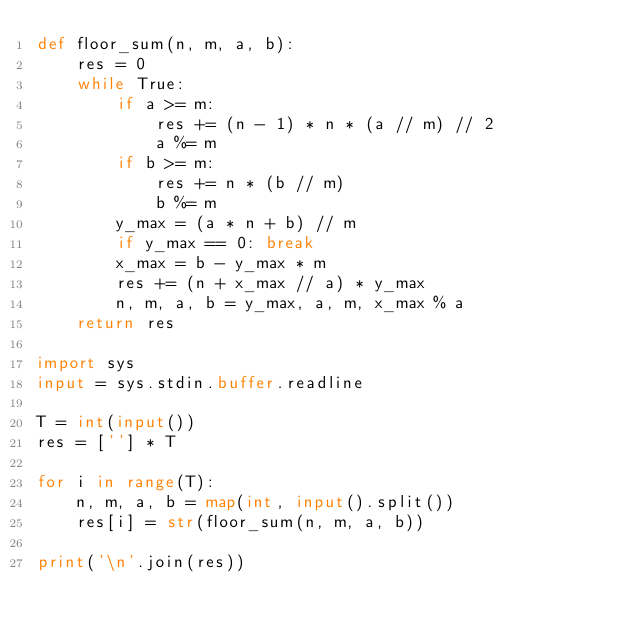Convert code to text. <code><loc_0><loc_0><loc_500><loc_500><_Python_>def floor_sum(n, m, a, b):
    res = 0
    while True:
        if a >= m:
            res += (n - 1) * n * (a // m) // 2
            a %= m
        if b >= m:
            res += n * (b // m)
            b %= m
        y_max = (a * n + b) // m
        if y_max == 0: break
        x_max = b - y_max * m
        res += (n + x_max // a) * y_max
        n, m, a, b = y_max, a, m, x_max % a
    return res

import sys
input = sys.stdin.buffer.readline

T = int(input())
res = [''] * T

for i in range(T):
    n, m, a, b = map(int, input().split())
    res[i] = str(floor_sum(n, m, a, b))

print('\n'.join(res))</code> 